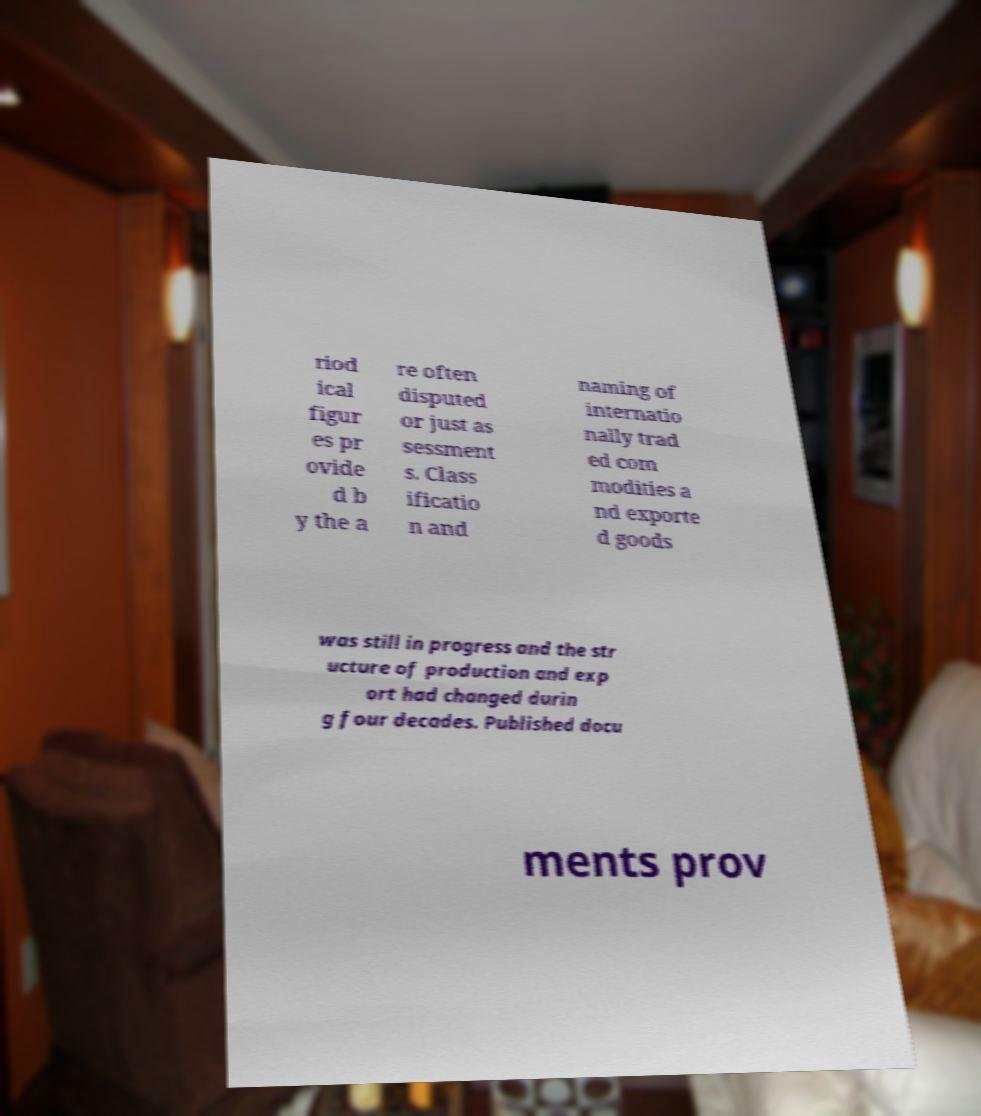I need the written content from this picture converted into text. Can you do that? riod ical figur es pr ovide d b y the a re often disputed or just as sessment s. Class ificatio n and naming of internatio nally trad ed com modities a nd exporte d goods was still in progress and the str ucture of production and exp ort had changed durin g four decades. Published docu ments prov 